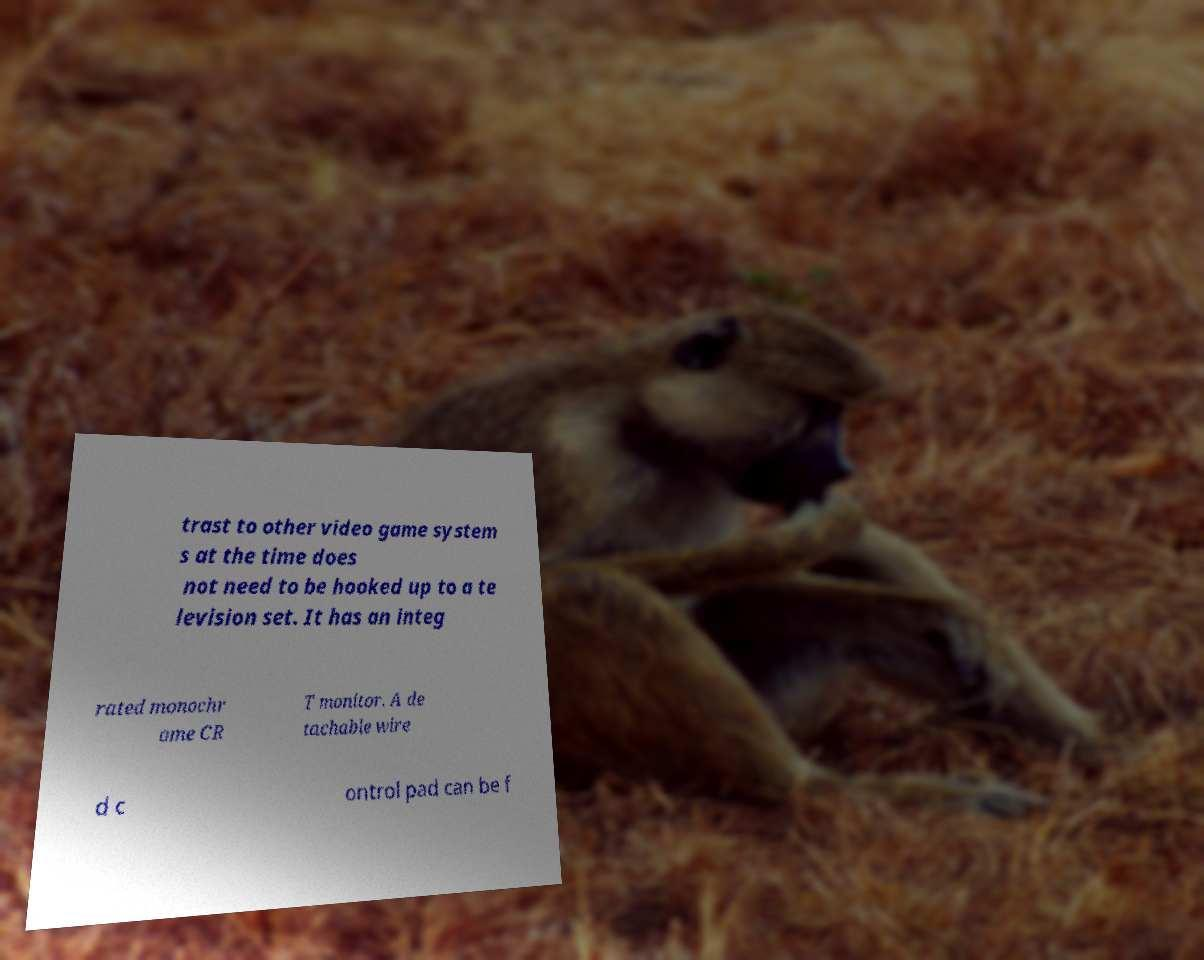Can you accurately transcribe the text from the provided image for me? trast to other video game system s at the time does not need to be hooked up to a te levision set. It has an integ rated monochr ome CR T monitor. A de tachable wire d c ontrol pad can be f 